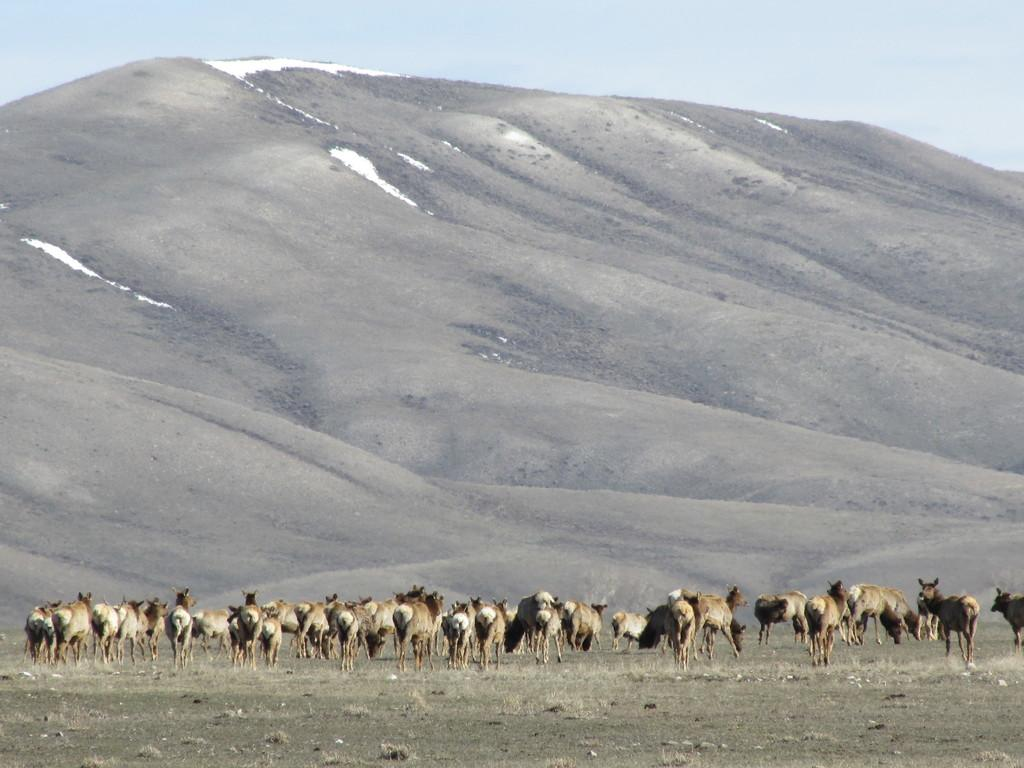What type of animals can be seen on the ground in the image? The specific type of animals is not mentioned, but there are animals on the ground in the image. What can be seen in the distance behind the animals? There are mountains in the background of the image. What color is the sky in the image? The sky is blue in the image. How many brothers are present in the image? There is no mention of brothers in the image, as it features animals on the ground, mountains in the background, and a blue sky. 